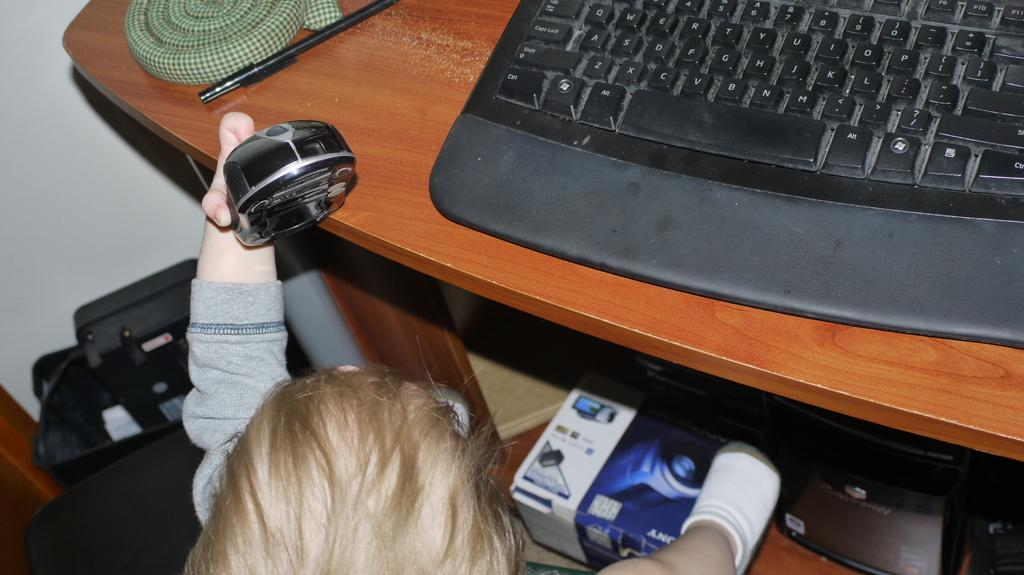What is the main object in the image? There is a keyboard in the image. What other object can be seen in the image? There is a pen in the image. Who is present in the image? There is a kid in the image. What is the kid holding in her hand? The kid is holding an object in her hand. How does the image depict the level of pollution in the area? The image does not depict or mention any level of pollution; it only shows a keyboard, a pen, and a kid holding an object. 